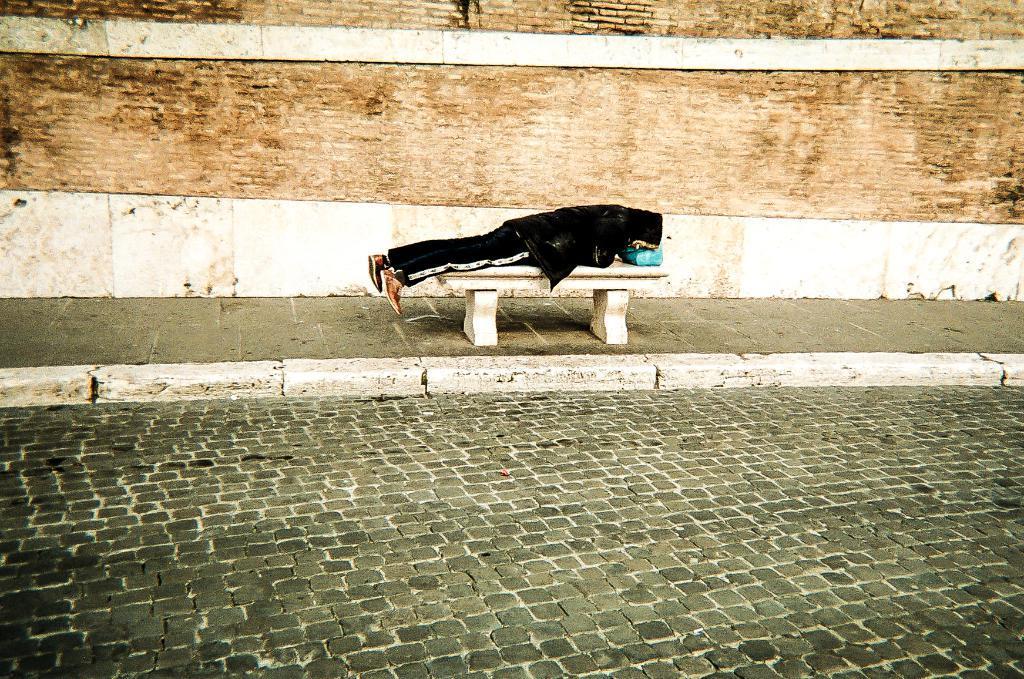Can you describe this image briefly? In this image we can see a person is lying on the bench. At the bottom of the image road is there. Background of the image brick wall is present. 